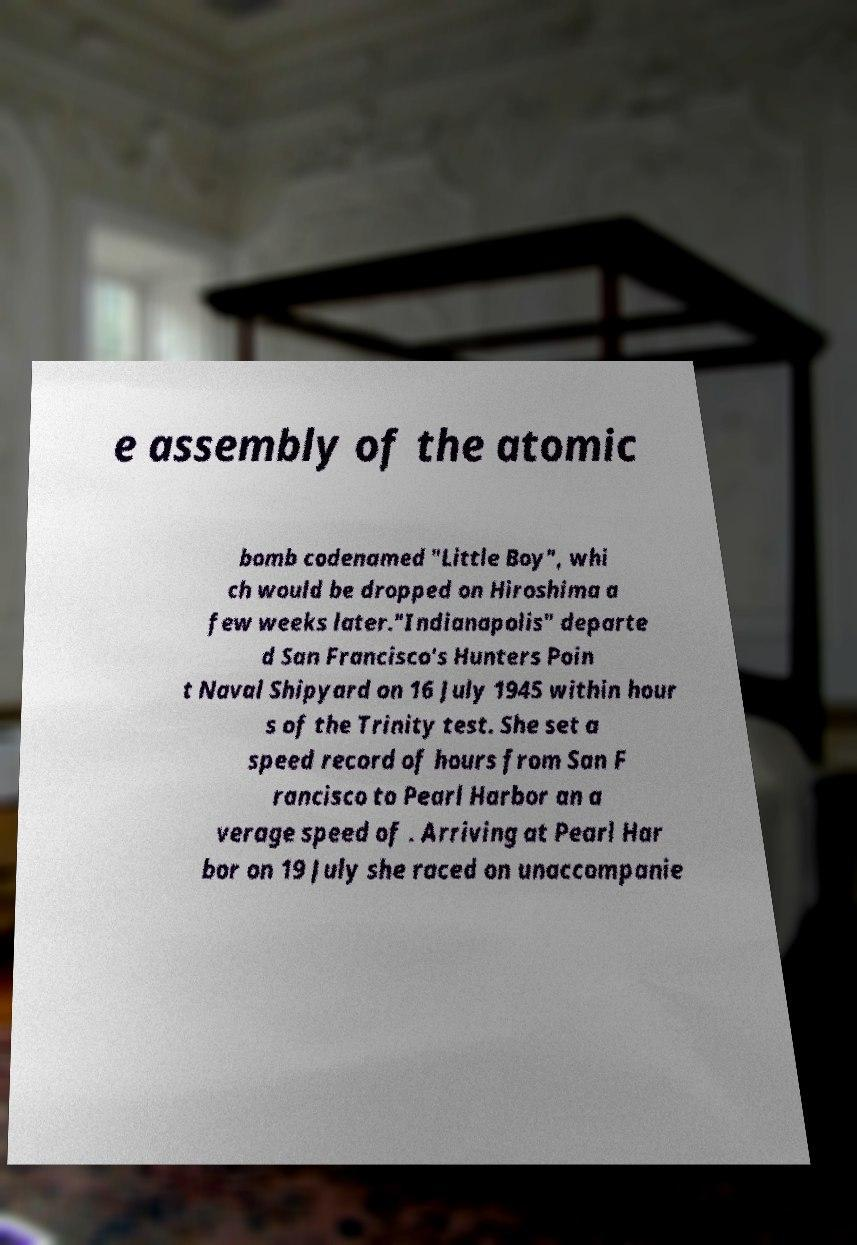Can you accurately transcribe the text from the provided image for me? e assembly of the atomic bomb codenamed "Little Boy", whi ch would be dropped on Hiroshima a few weeks later."Indianapolis" departe d San Francisco's Hunters Poin t Naval Shipyard on 16 July 1945 within hour s of the Trinity test. She set a speed record of hours from San F rancisco to Pearl Harbor an a verage speed of . Arriving at Pearl Har bor on 19 July she raced on unaccompanie 